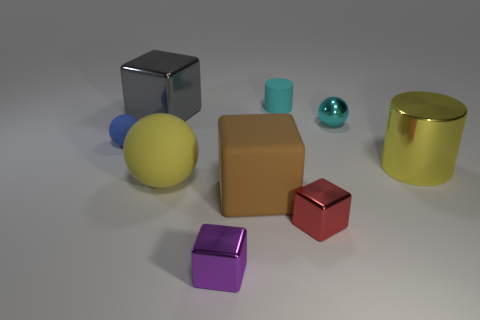There is a small thing behind the large cube behind the big metal thing on the right side of the tiny cyan cylinder; what shape is it?
Your answer should be compact. Cylinder. There is a blue ball; is its size the same as the block that is left of the yellow matte ball?
Give a very brief answer. No. What shape is the tiny thing that is to the right of the tiny cylinder and in front of the small blue rubber ball?
Offer a very short reply. Cube. What number of big objects are either blue things or green shiny balls?
Your answer should be compact. 0. Are there the same number of red metal blocks on the left side of the tiny blue object and balls on the right side of the tiny red object?
Make the answer very short. No. What number of other things are there of the same color as the big cylinder?
Provide a succinct answer. 1. Are there the same number of big yellow metal cylinders in front of the yellow metal cylinder and big red things?
Offer a very short reply. Yes. Is the size of the yellow rubber thing the same as the brown matte object?
Offer a terse response. Yes. What material is the big thing that is both right of the purple metal object and behind the large brown matte block?
Keep it short and to the point. Metal. What number of other small matte things are the same shape as the blue rubber object?
Your answer should be very brief. 0. 